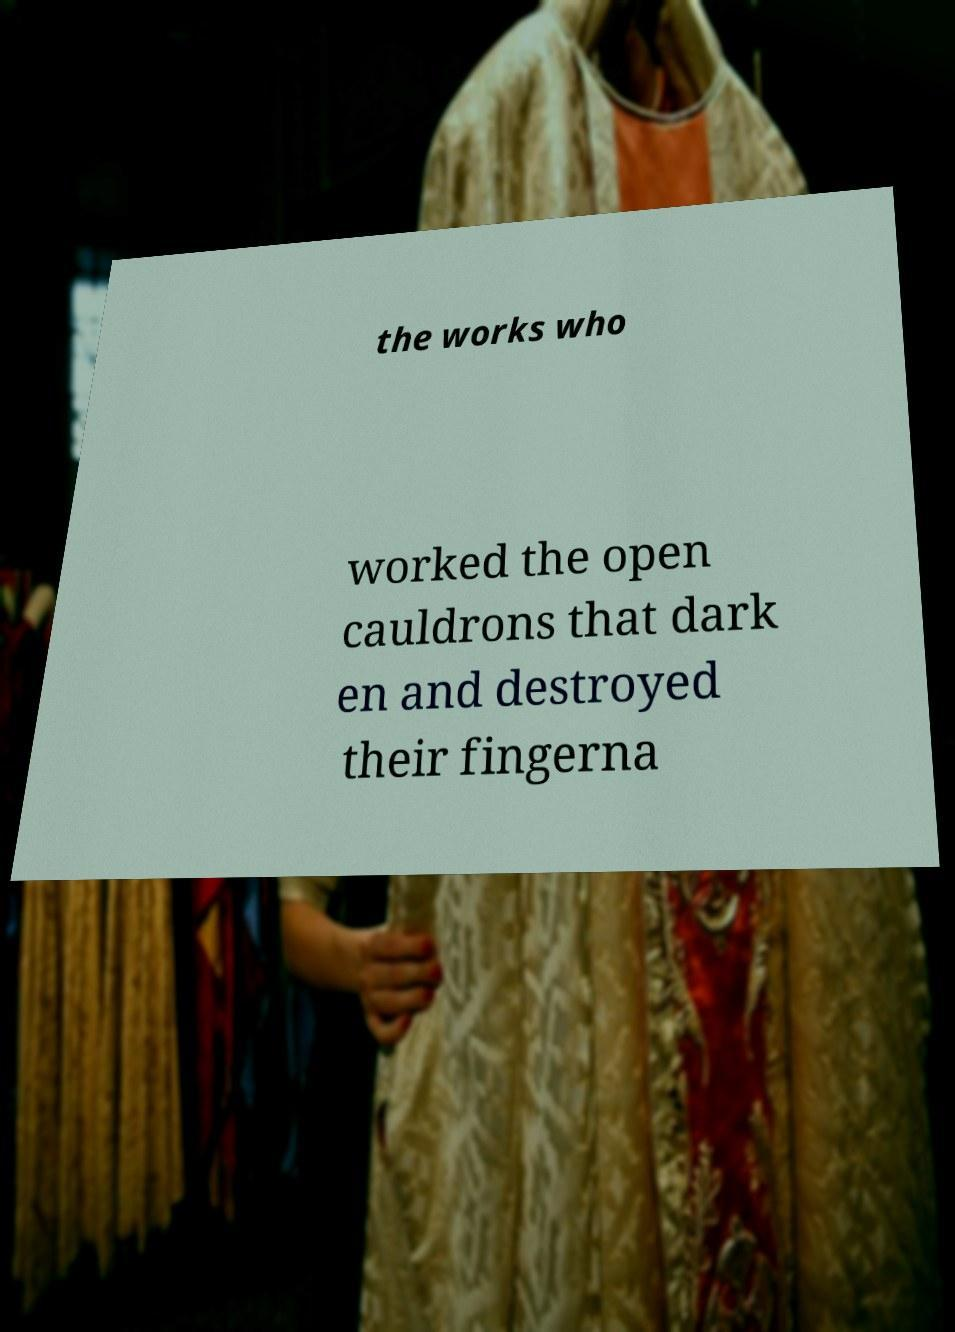Please identify and transcribe the text found in this image. the works who worked the open cauldrons that dark en and destroyed their fingerna 